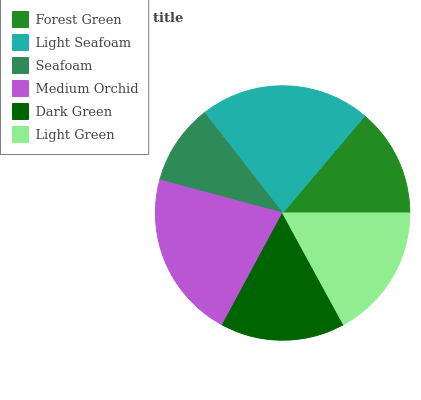Is Seafoam the minimum?
Answer yes or no. Yes. Is Light Seafoam the maximum?
Answer yes or no. Yes. Is Light Seafoam the minimum?
Answer yes or no. No. Is Seafoam the maximum?
Answer yes or no. No. Is Light Seafoam greater than Seafoam?
Answer yes or no. Yes. Is Seafoam less than Light Seafoam?
Answer yes or no. Yes. Is Seafoam greater than Light Seafoam?
Answer yes or no. No. Is Light Seafoam less than Seafoam?
Answer yes or no. No. Is Light Green the high median?
Answer yes or no. Yes. Is Dark Green the low median?
Answer yes or no. Yes. Is Seafoam the high median?
Answer yes or no. No. Is Light Green the low median?
Answer yes or no. No. 